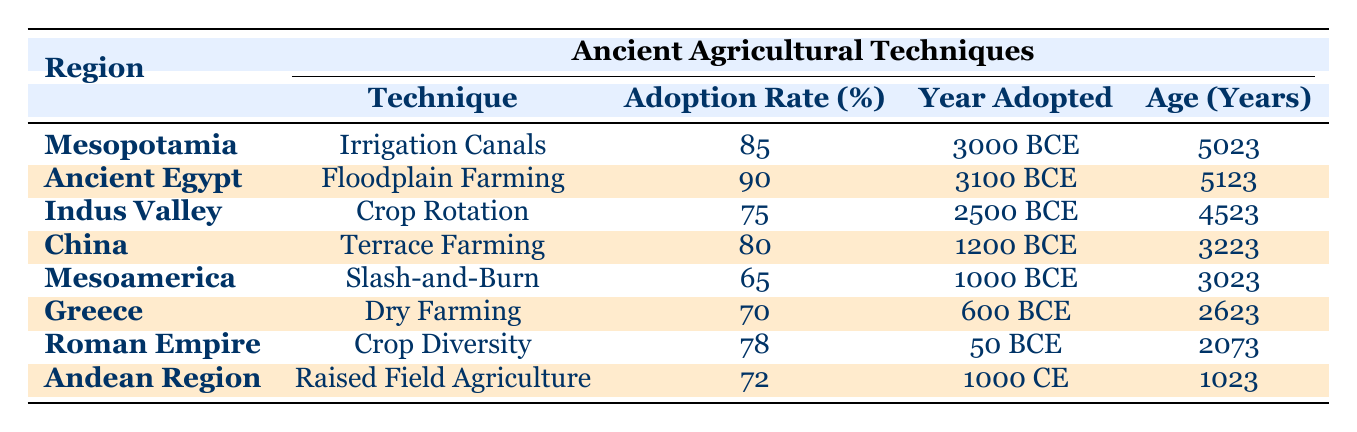What ancient agricultural technique had the highest adoption rate? From the table, I can see that Ancient Egypt's Floodplain Farming has an adoption rate of 90%, which is the highest compared to the other techniques listed.
Answer: Floodplain Farming Which region adopted crop rotation, and what was its adoption rate? Looking at the table, the Indus Valley adopted Crop Rotation with an adoption rate of 75%.
Answer: Indus Valley, 75% How many years ago was Irrigation Canals adopted in Mesopotamia? The year adopted for Irrigation Canals in Mesopotamia is 3000 BCE, and since the current year is 2023 CE, that totals 5023 years ago (3000 + 2023 = 5023).
Answer: 5023 years ago What is the median adoption rate of the techniques listed? First, I will list the adoption rates: 85, 90, 75, 80, 65, 70, 78, and 72. Arranging them in order gives: 65, 70, 72, 75, 78, 80, 85, 90. There are 8 values, and the median is the average of the middle two (75 and 78), which is (75 + 78)/2 = 76.5.
Answer: 76.5 Is it true that the Roman Empire had a higher adoption rate than Greece? According to the table, the Roman Empire had an adoption rate of 78%, while Greece had a rate of 70%. Since 78% is greater than 70%, the statement is true.
Answer: Yes Which technique was adopted most recently and in which region? The last mentioned technique in chronological terms is Raised Field Agriculture, adopted in the Andean Region in 1000 CE, making it the most recent in the table.
Answer: Raised Field Agriculture, Andean Region What was the average age of adoption of the techniques listed? To find the average age, I calculate the ages of all techniques: 5023, 5123, 4523, 3223, 3023, 2623, 2073, and 1023, resulting in a sum of 22494. Dividing this by the 8 regions gives an average age of 22494/8 = 2811.75 years.
Answer: 2811.75 years Was Mesoamerica among the top three regions with the highest adoption rates? The adoption rates in descending order are 90%, 85%, 80%, 78%, 75%, 72%, 70%, and 65% for Mesoamerica. Mesoamerica's rate of 65% is not in the top three. Therefore, the statement is false.
Answer: No 